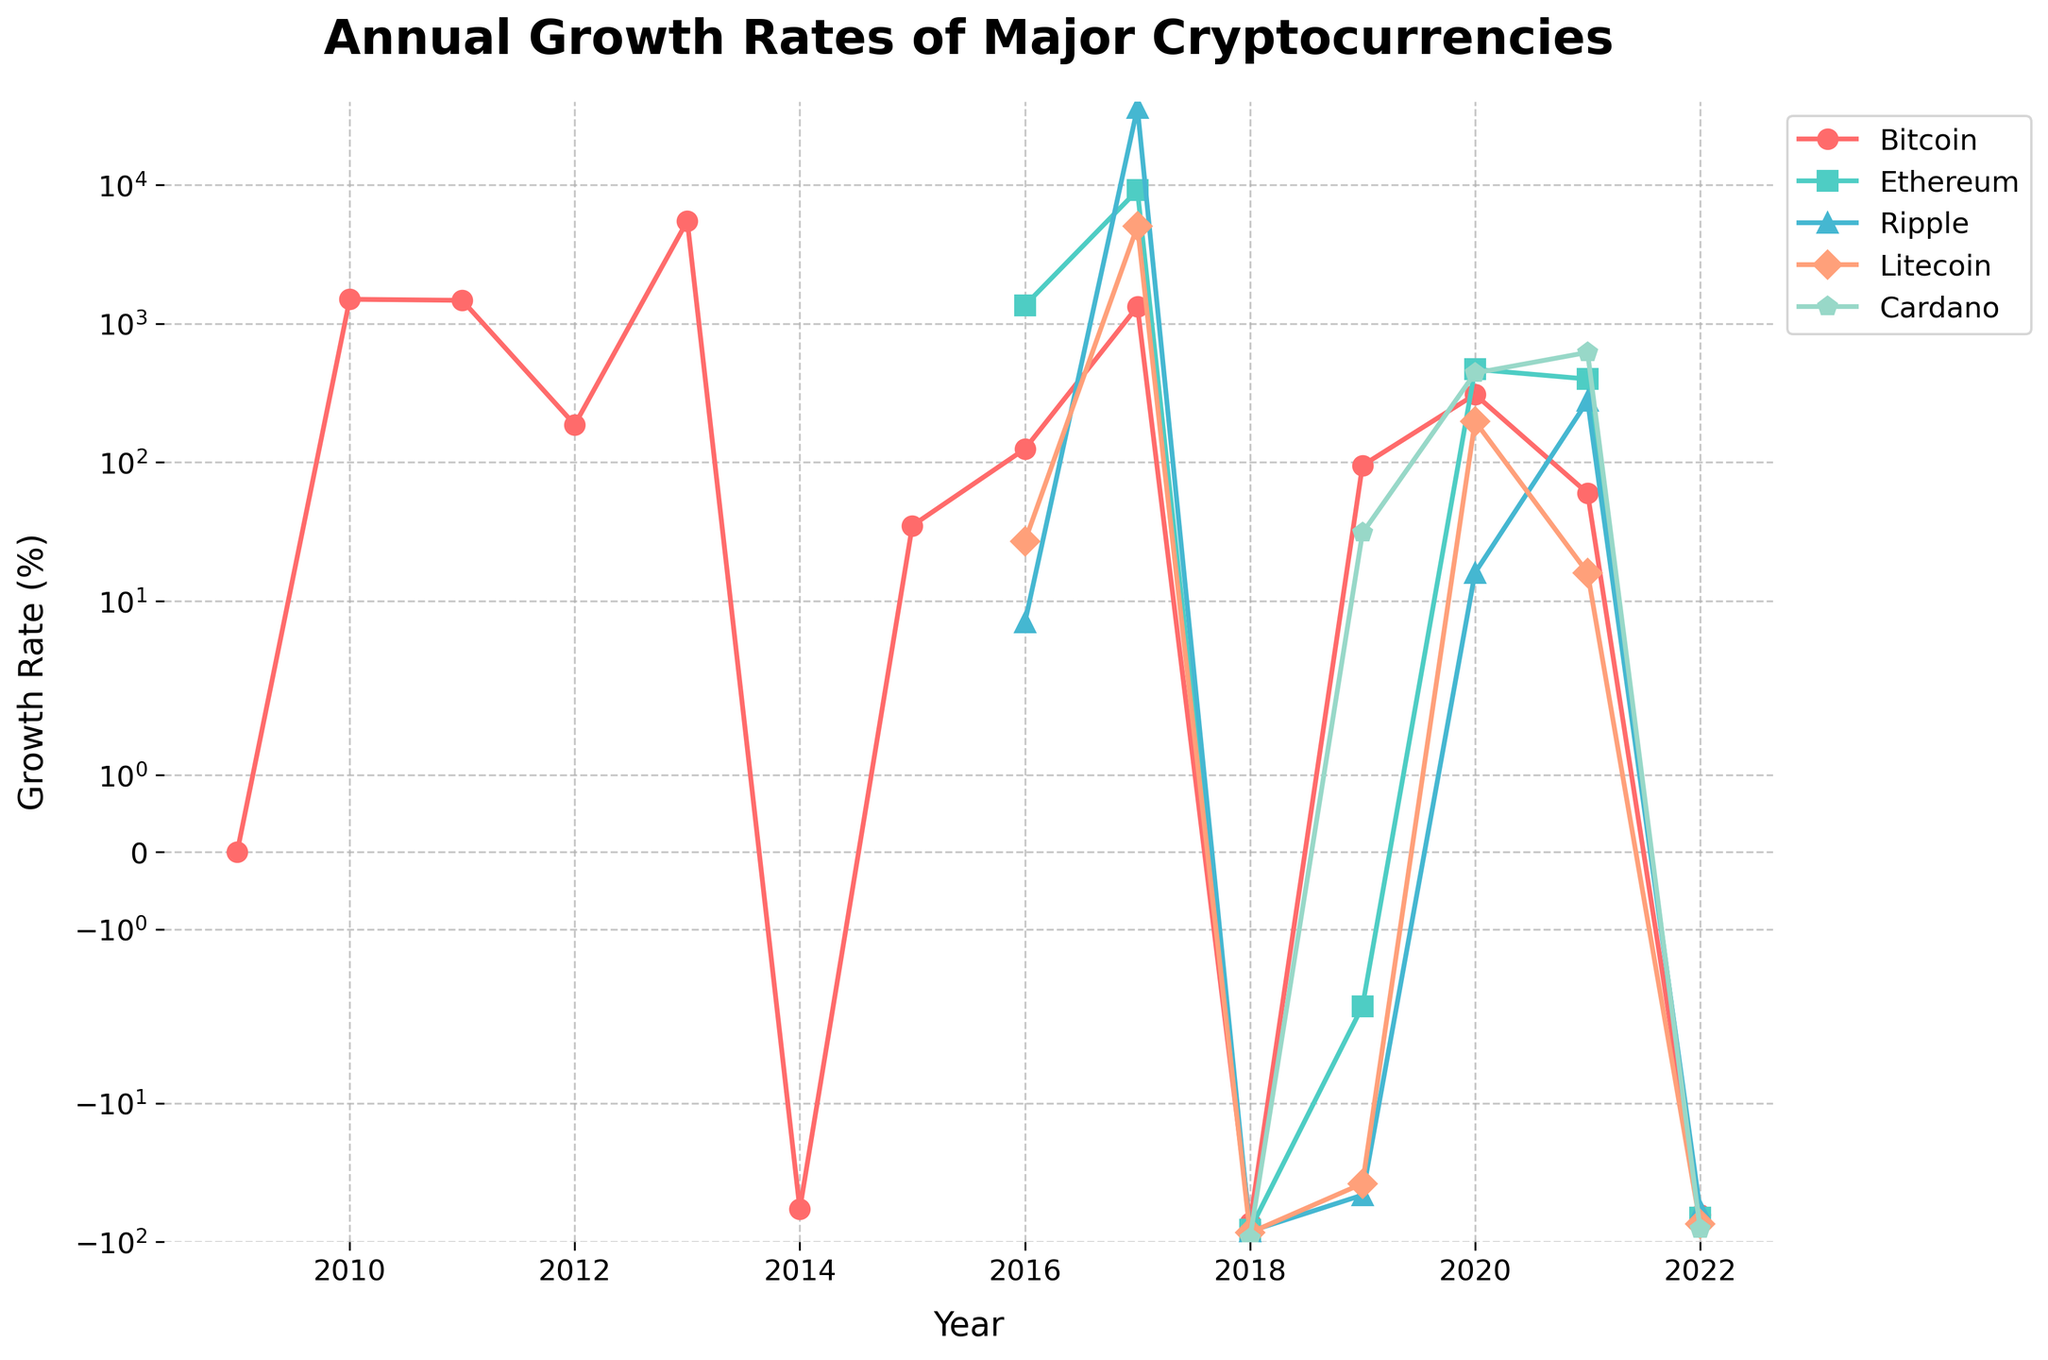What was the highest annual growth rate achieved by Bitcoin, and in which year did it occur? To find the highest annual growth rate for Bitcoin, look at the line plot for Bitcoin and identify the highest point. From the figure, the highest point for Bitcoin corresponds to the year 2013 with a growth rate of 5507%.
Answer: 5507% in 2013 Compare the annual growth rates of Ripple and Cardano in 2017. Which one had a higher growth rate? Look at the line plot for Ripple and Cardano in the year 2017. Ripple's growth rate was marked higher than Cardano's growth rate in 2017.
Answer: Ripple Between 2018 and 2021, which cryptocurrency experienced the most significant drop in growth rate? To determine the most significant drop, compare the growth rates from 2018 to 2021 for all cryptocurrencies. Ripple shows a decrease from 36018% in 2017 to -84% in 2018. Although the drop for all currencies is negative post-2017, Ripple's rate falls drastically by several thousand percentage points.
Answer: Ripple Which cryptocurrency had the steadiest growth rate from 2019 to 2021? Steadier growth rates imply less fluctuation year-to-year. By visually inspecting the transitions from 2019 to 2021, Bitcoin remains relatively more stable compared to the others which show substantial up-and-down changes.
Answer: Bitcoin In what year did Ethereum experience its highest annual growth, and what was the growth rate? Look at the Ethereum line and identify the highest point on the plot. The highest point for Ethereum occurs in 2017, with an annual growth rate of 9162%.
Answer: 9162% in 2017 What are the growth rates of Litecoin and Cardano in 2019, and which one is higher? Check the line plots for Litecoin and Cardano at the year 2019. Litecoin had a growth rate of -38%, while Cardano had a growth rate of 31%. Hence, Cardano's growth rate is higher in 2019.
Answer: Cardano with 31% Calculate the average annual growth rate of Ethereum between 2016 and 2018. Add the growth rates of Ethereum for the years 2016, 2017, and 2018 and divide by the number of years. The calculation is (1355 + 9162 - 82) / 3. This equals 8305 / 3 which approximates to 2768.33%.
Answer: 2768.33% How did the growth rate of Bitcoin change from 2020 to 2021? Identify the growth rates of Bitcoin for the years 2020 and 2021. In 2020, Bitcoin's growth rate was 309%, and in 2021, it was 60%. The change in growth rate can be calculated as 60% - 309%, which shows a decrease of 249%.
Answer: Decreased by 249% By how much did the annual growth rate of Cardano differ between 2020 and 2022? Check the annual growth rates of Cardano for 2020 and 2022. For 2020, it was 441%, and for 2022, it was -81%. The difference is calculated as 441% - (-81%) = 522%.
Answer: 522% Which cryptocurrency exhibited positive growth in the year 2019, and what were their growth rates? From the line plot, identify the cryptocurrencies with positive growth rates in 2019. Bitcoin and Cardano had positive growth rates in 2019. Bitcoin's rate was 95%, and Cardano's rate was 31%.
Answer: Bitcoin and Cardano with 95% and 31% respectively 